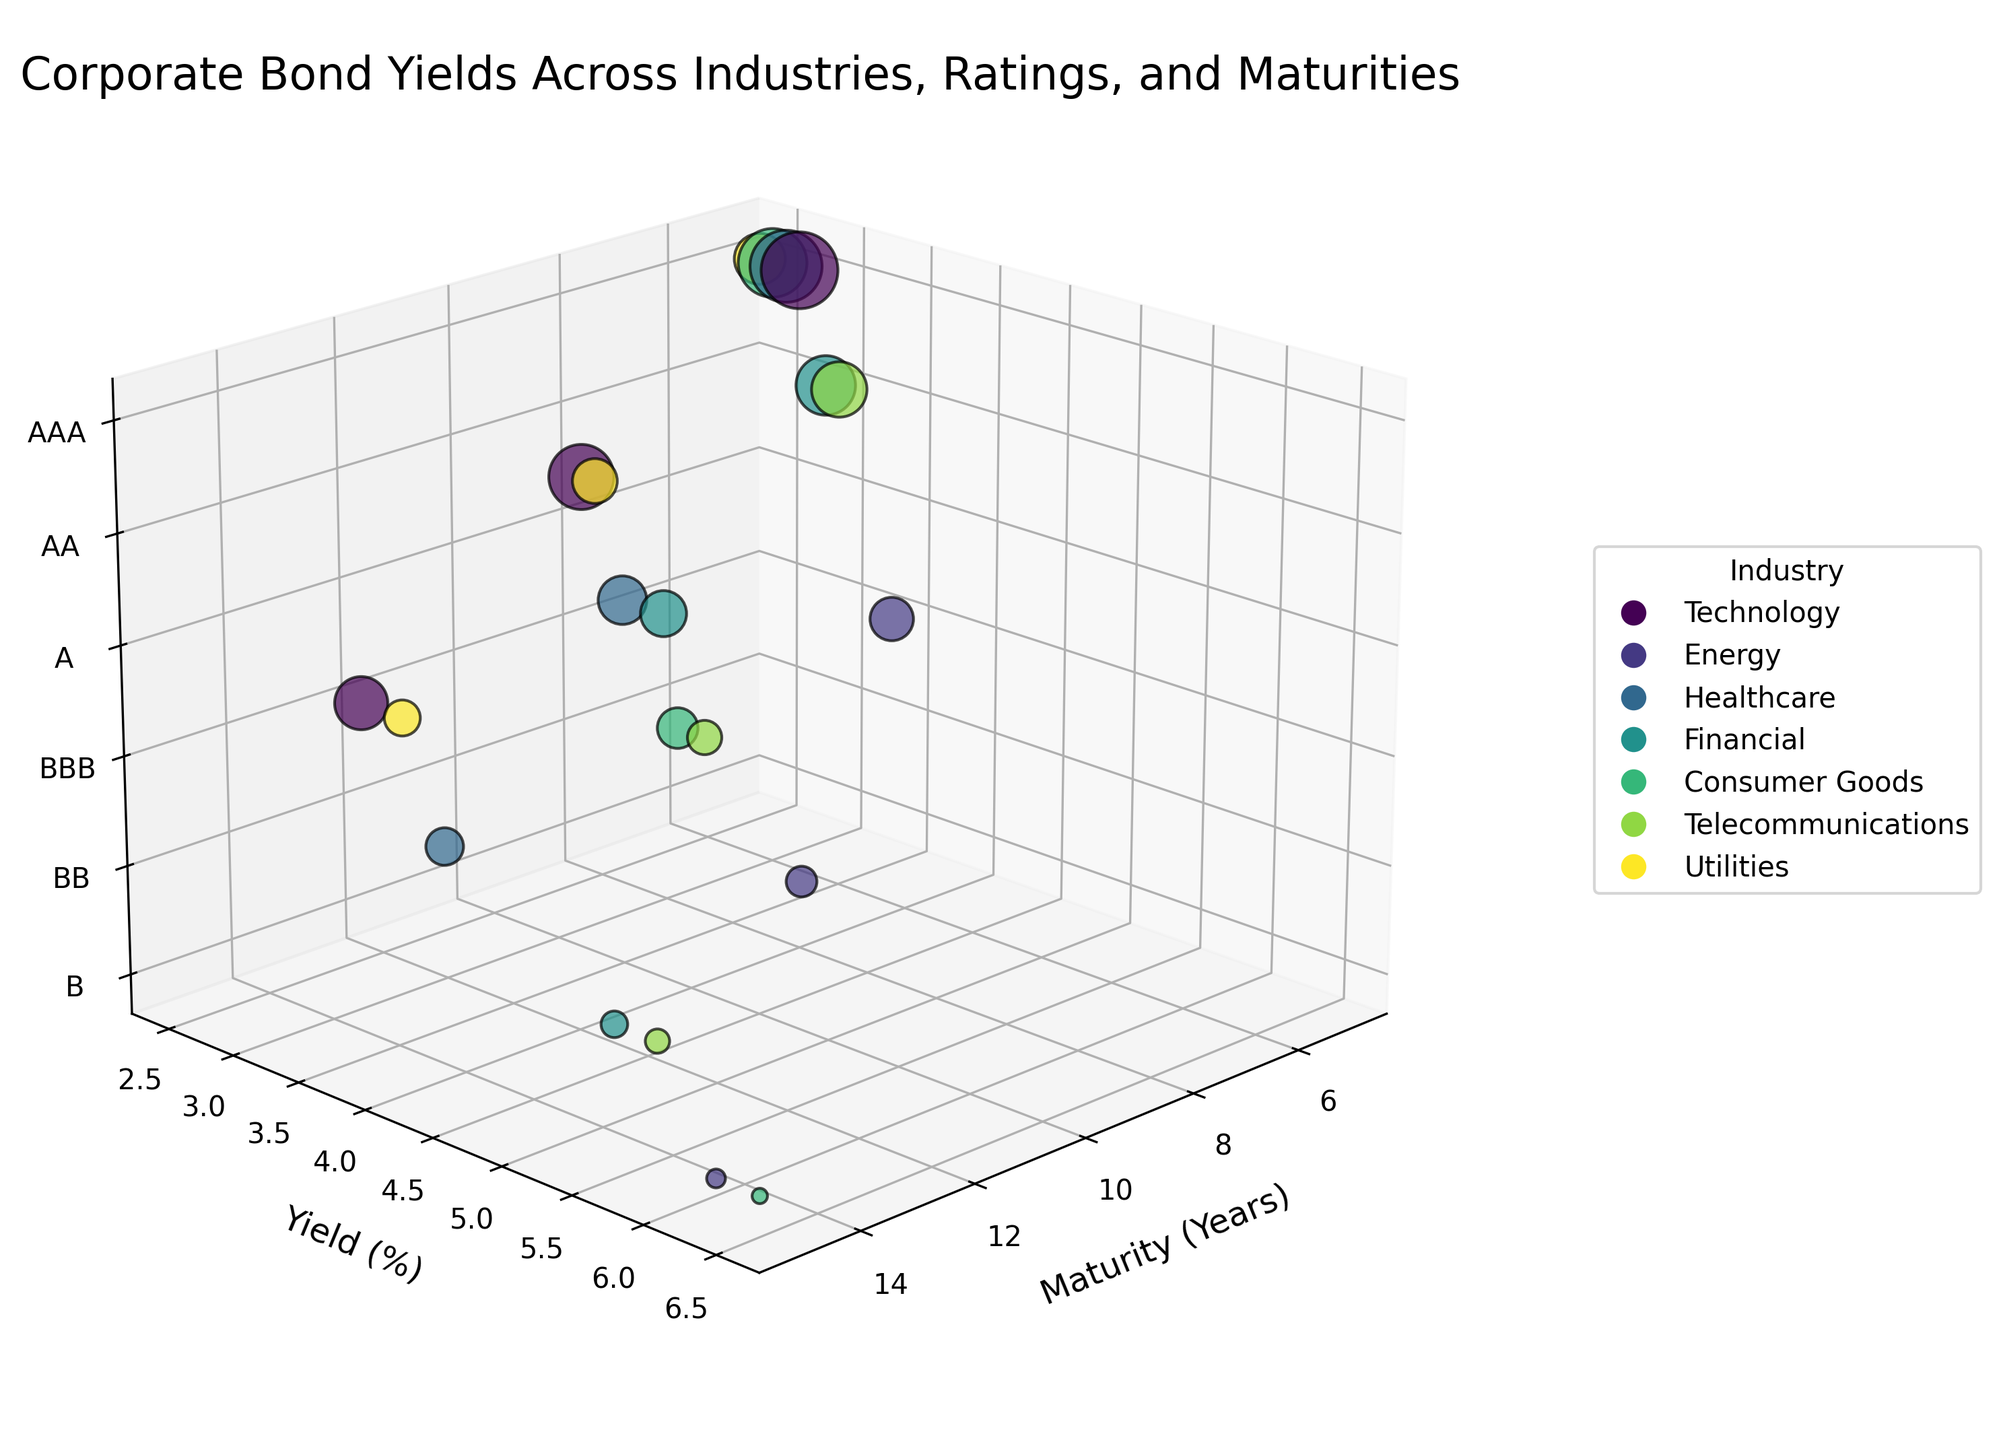What does the title of the chart indicate? The title of the chart is "Corporate Bond Yields Across Industries, Ratings, and Maturities." This indicates that the chart shows data points on bond yields, categorized by various industries, credit ratings, and maturity periods.
Answer: Corporate Bond Yields Across Industries, Ratings, and Maturities What are the variables represented on the three axes? The x-axis represents "Maturity (Years)," the y-axis represents "Yield (%)," and the z-axis represents "Credit Rating" mapped to a numeric scale.
Answer: Maturity (Years), Yield (%), and Credit Rating How is the size of each bubble determined? The size of each bubble is determined by the market capitalization (Market Cap in Billions) of the company or industry. Larger market caps correspond to bigger bubbles.
Answer: Market Cap (Billions) Which industry has the highest yield at 15 years maturity? By examining the chart, the Energy industry shows higher yields compared to other industries at 15 years maturity, specifically 6.2%.
Answer: Energy What are the credit ratings used in the chart, and how are they represented numerically? The credit ratings used in the chart are AAA, AA, A, BBB, BB, and B. These are represented numerically as 3, 2, 1, 0, -1, and -2, respectively.
Answer: AAA (3), AA (2), A (1), BBB (0), BB (-1), B (-2) Which industry has the lowest yield for an AAA rated bond? The lowest yield for an AAA rated bond, as seen in the chart, is in the Utilities industry with a yield of 2.5%.
Answer: Utilities Compare the bond yields between the Financial and Telecommunications industries for AA rated bonds. The Financial industry has an AA rated bond yield of 3.0%, whereas the Telecommunications industry has an AA rated bond yield of 3.1%. Therefore, the Telecommunications yield is slightly higher.
Answer: Telecommunications Which industry has the highest market cap for bonds with a 10-year maturity? Looking at the size of the bubbles, the Technology industry has the highest market cap for bonds with a 10-year maturity.
Answer: Technology What is the difference in yield between AAA and BBB rated bonds in the Healthcare industry with a 5-year maturity? For the Healthcare industry with a 5-year maturity, AAA rated bonds have a yield of 2.7% and BBB rated bonds have a yield of 4.3%. The difference in yield is 4.3% - 2.7% = 1.6%.
Answer: 1.6% Do bonds with lower credit ratings always have higher yields within the same industry? Comparing the yields within the same industry, bonds with lower credit ratings generally have higher yields. For instance, in the Technology industry, the yields increase from 2.8% (AAA) to 3.2% (AA) to 3.7% (A). This trend is observed across all industries represented in the chart.
Answer: Yes 